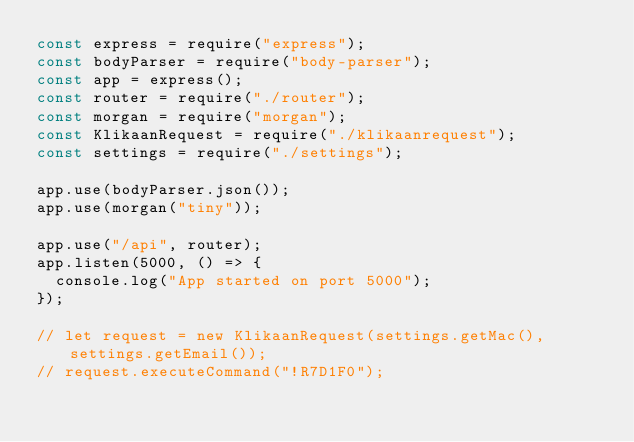<code> <loc_0><loc_0><loc_500><loc_500><_JavaScript_>const express = require("express");
const bodyParser = require("body-parser");
const app = express();
const router = require("./router");
const morgan = require("morgan");
const KlikaanRequest = require("./klikaanrequest");
const settings = require("./settings");

app.use(bodyParser.json());
app.use(morgan("tiny"));

app.use("/api", router);
app.listen(5000, () => {
  console.log("App started on port 5000");
});

// let request = new KlikaanRequest(settings.getMac(), settings.getEmail());
// request.executeCommand("!R7D1F0");
</code> 